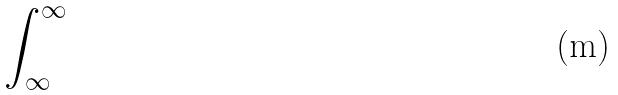<formula> <loc_0><loc_0><loc_500><loc_500>\int _ { \infty } ^ { \infty }</formula> 